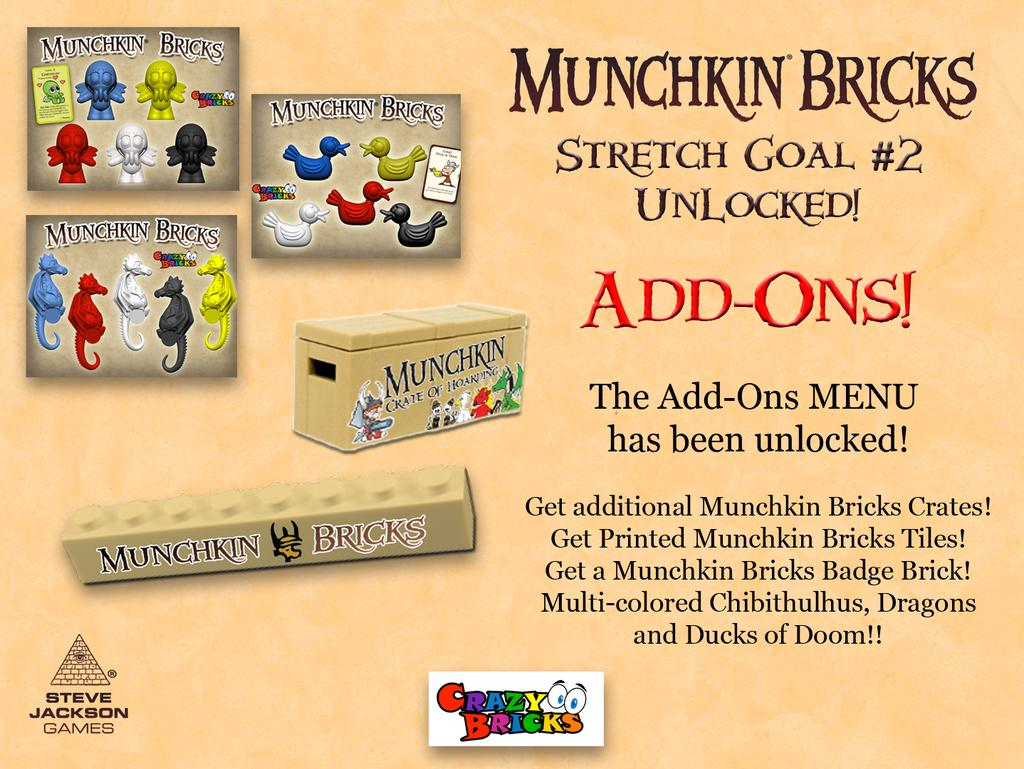<image>
Summarize the visual content of the image. An advertisement for Munchkin Bricks promotes add ons. 